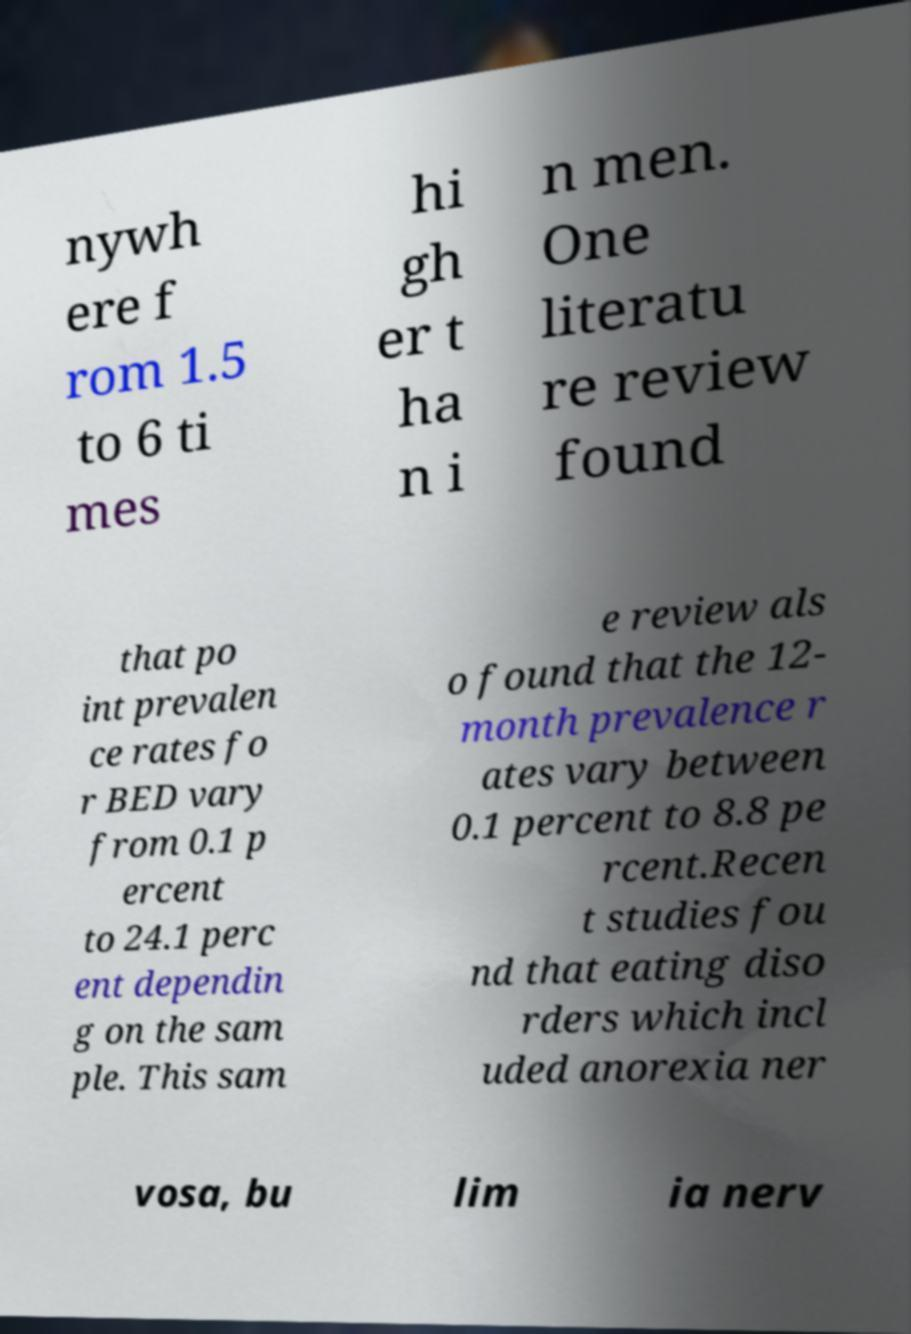Could you extract and type out the text from this image? nywh ere f rom 1.5 to 6 ti mes hi gh er t ha n i n men. One literatu re review found that po int prevalen ce rates fo r BED vary from 0.1 p ercent to 24.1 perc ent dependin g on the sam ple. This sam e review als o found that the 12- month prevalence r ates vary between 0.1 percent to 8.8 pe rcent.Recen t studies fou nd that eating diso rders which incl uded anorexia ner vosa, bu lim ia nerv 